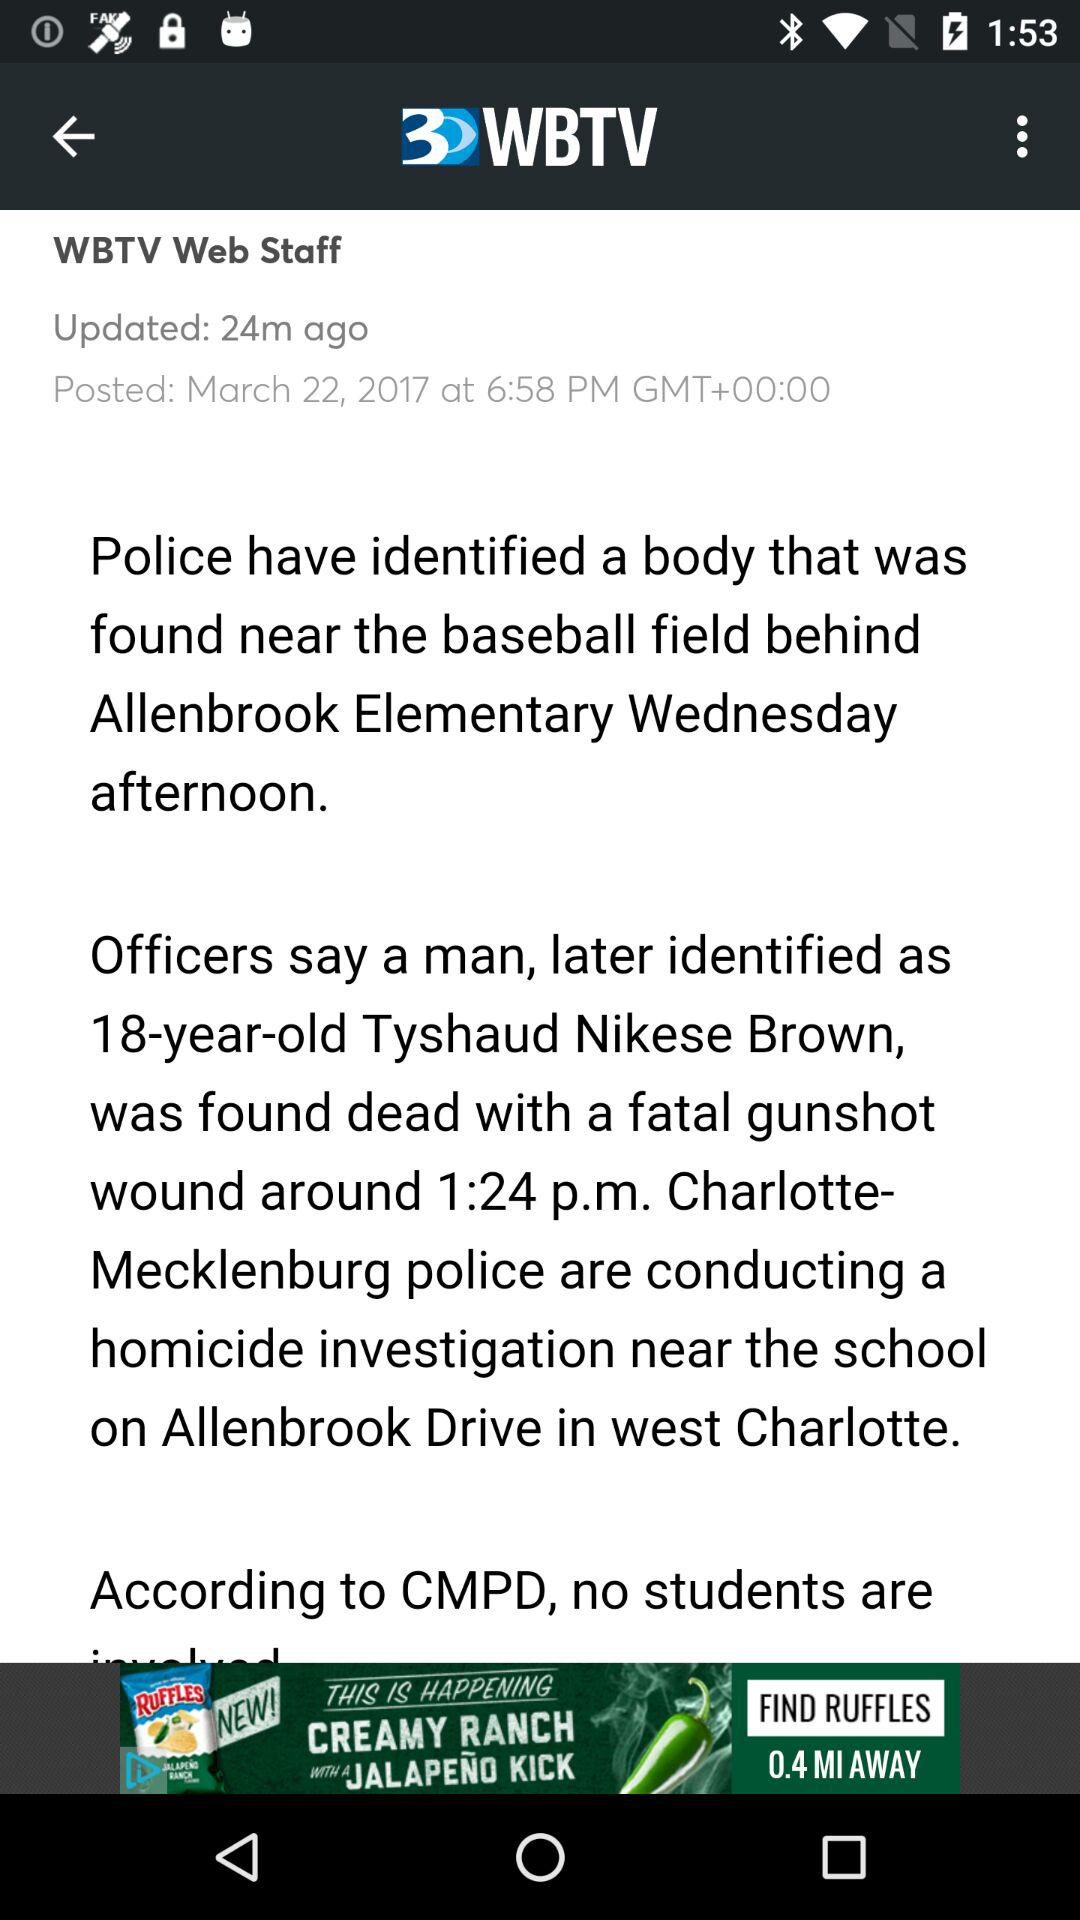When was the article last updated? The article was last updated 24 minutes ago. 